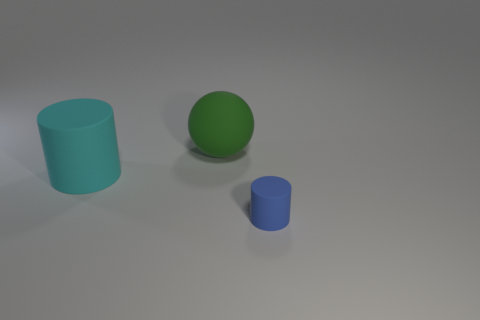The rubber thing that is both in front of the large matte sphere and to the left of the tiny blue matte cylinder is what color?
Your answer should be compact. Cyan. What is the shape of the cyan object that is the same size as the green thing?
Your answer should be very brief. Cylinder. Is there another sphere that has the same color as the large ball?
Offer a very short reply. No. Are there the same number of large cyan cylinders that are behind the cyan object and metallic balls?
Provide a short and direct response. Yes. Do the tiny rubber cylinder and the sphere have the same color?
Offer a terse response. No. What is the size of the rubber thing that is both in front of the sphere and to the left of the small blue object?
Ensure brevity in your answer.  Large. The big ball that is made of the same material as the small thing is what color?
Keep it short and to the point. Green. How many other things have the same material as the small blue thing?
Ensure brevity in your answer.  2. Is the number of large green balls on the left side of the large green rubber object the same as the number of big matte things on the right side of the tiny thing?
Your answer should be very brief. Yes. Does the cyan rubber object have the same shape as the rubber thing behind the cyan matte cylinder?
Your answer should be compact. No. 